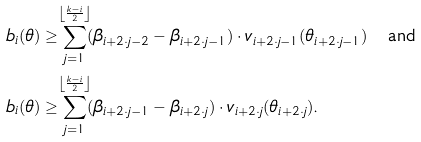<formula> <loc_0><loc_0><loc_500><loc_500>b _ { i } ( \theta ) & \geq \sum _ { j = 1 } ^ { \mathclap { \left \lfloor \frac { k - i } { 2 } \right \rfloor } } ( \beta _ { i + 2 \cdot j - 2 } - \beta _ { i + 2 \cdot j - 1 } ) \cdot v _ { i + 2 \cdot j - 1 } ( \theta _ { i + 2 \cdot j - 1 } ) \quad \text {and} \\ b _ { i } ( \theta ) & \geq \sum _ { j = 1 } ^ { \mathclap { \left \lfloor \frac { k - i } { 2 } \right \rfloor } } ( \beta _ { i + 2 \cdot j - 1 } - \beta _ { i + 2 \cdot j } ) \cdot v _ { i + 2 \cdot j } ( \theta _ { i + 2 \cdot j } ) \text {.}</formula> 